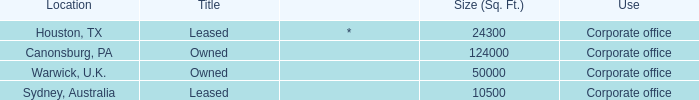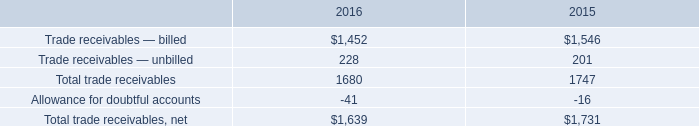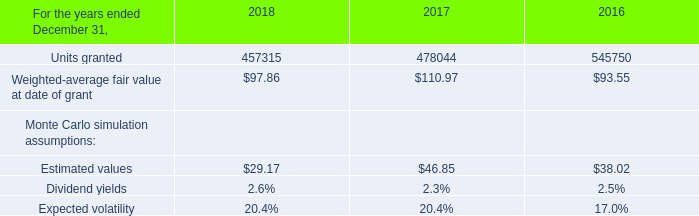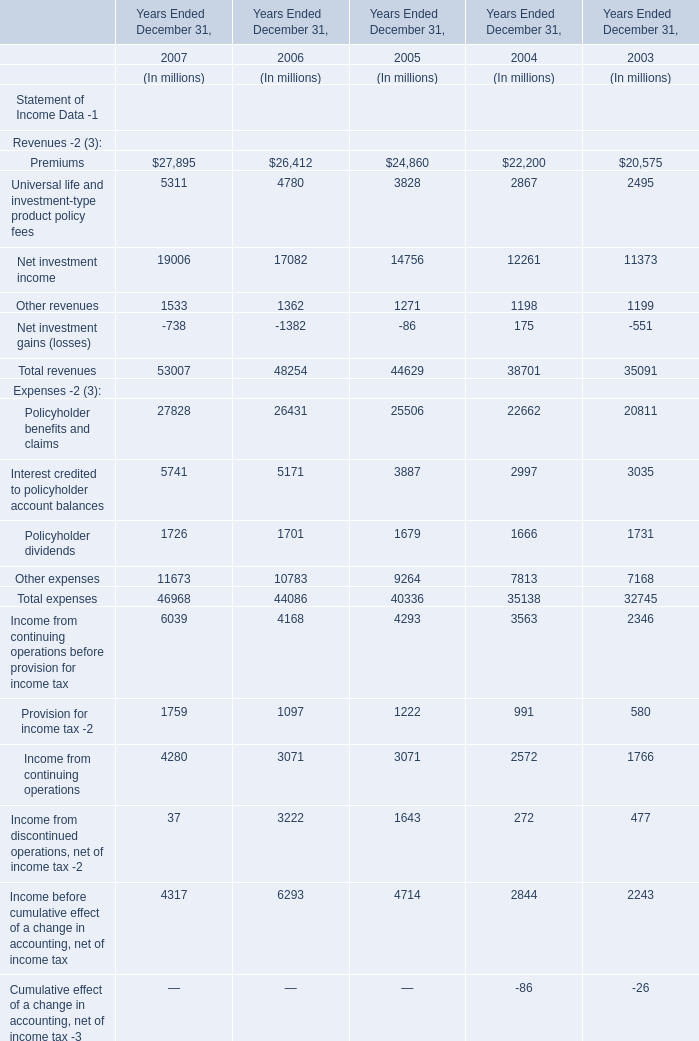what was the percentage change in total trade receivables net from 2015 to 2016? 
Computations: ((1639 - 1731) / 1731)
Answer: -0.05315. 